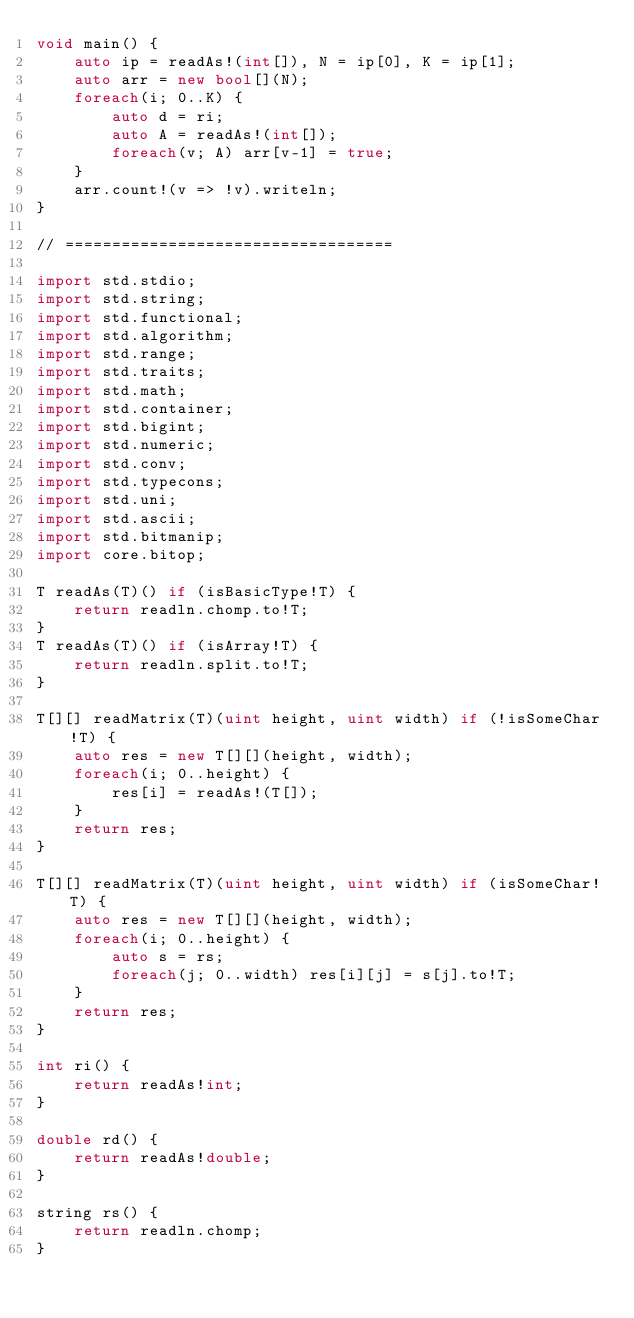<code> <loc_0><loc_0><loc_500><loc_500><_D_>void main() {
	auto ip = readAs!(int[]), N = ip[0], K = ip[1];
	auto arr = new bool[](N);
	foreach(i; 0..K) {
		auto d = ri;
		auto A = readAs!(int[]);
		foreach(v; A) arr[v-1] = true;
	}
	arr.count!(v => !v).writeln;
}

// ===================================

import std.stdio;
import std.string;
import std.functional;
import std.algorithm;
import std.range;
import std.traits;
import std.math;
import std.container;
import std.bigint;
import std.numeric;
import std.conv;
import std.typecons;
import std.uni;
import std.ascii;
import std.bitmanip;
import core.bitop;

T readAs(T)() if (isBasicType!T) {
	return readln.chomp.to!T;
}
T readAs(T)() if (isArray!T) {
	return readln.split.to!T;
}

T[][] readMatrix(T)(uint height, uint width) if (!isSomeChar!T) {
	auto res = new T[][](height, width);
	foreach(i; 0..height) {
		res[i] = readAs!(T[]);
	}
	return res;
}

T[][] readMatrix(T)(uint height, uint width) if (isSomeChar!T) {
	auto res = new T[][](height, width);
	foreach(i; 0..height) {
		auto s = rs;
		foreach(j; 0..width) res[i][j] = s[j].to!T;
	}
	return res;
}

int ri() {
	return readAs!int;
}

double rd() {
	return readAs!double;
}

string rs() {
	return readln.chomp;
}</code> 